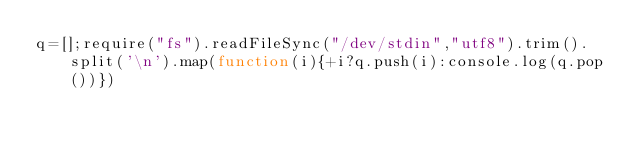Convert code to text. <code><loc_0><loc_0><loc_500><loc_500><_JavaScript_>q=[];require("fs").readFileSync("/dev/stdin","utf8").trim().split('\n').map(function(i){+i?q.push(i):console.log(q.pop())})</code> 